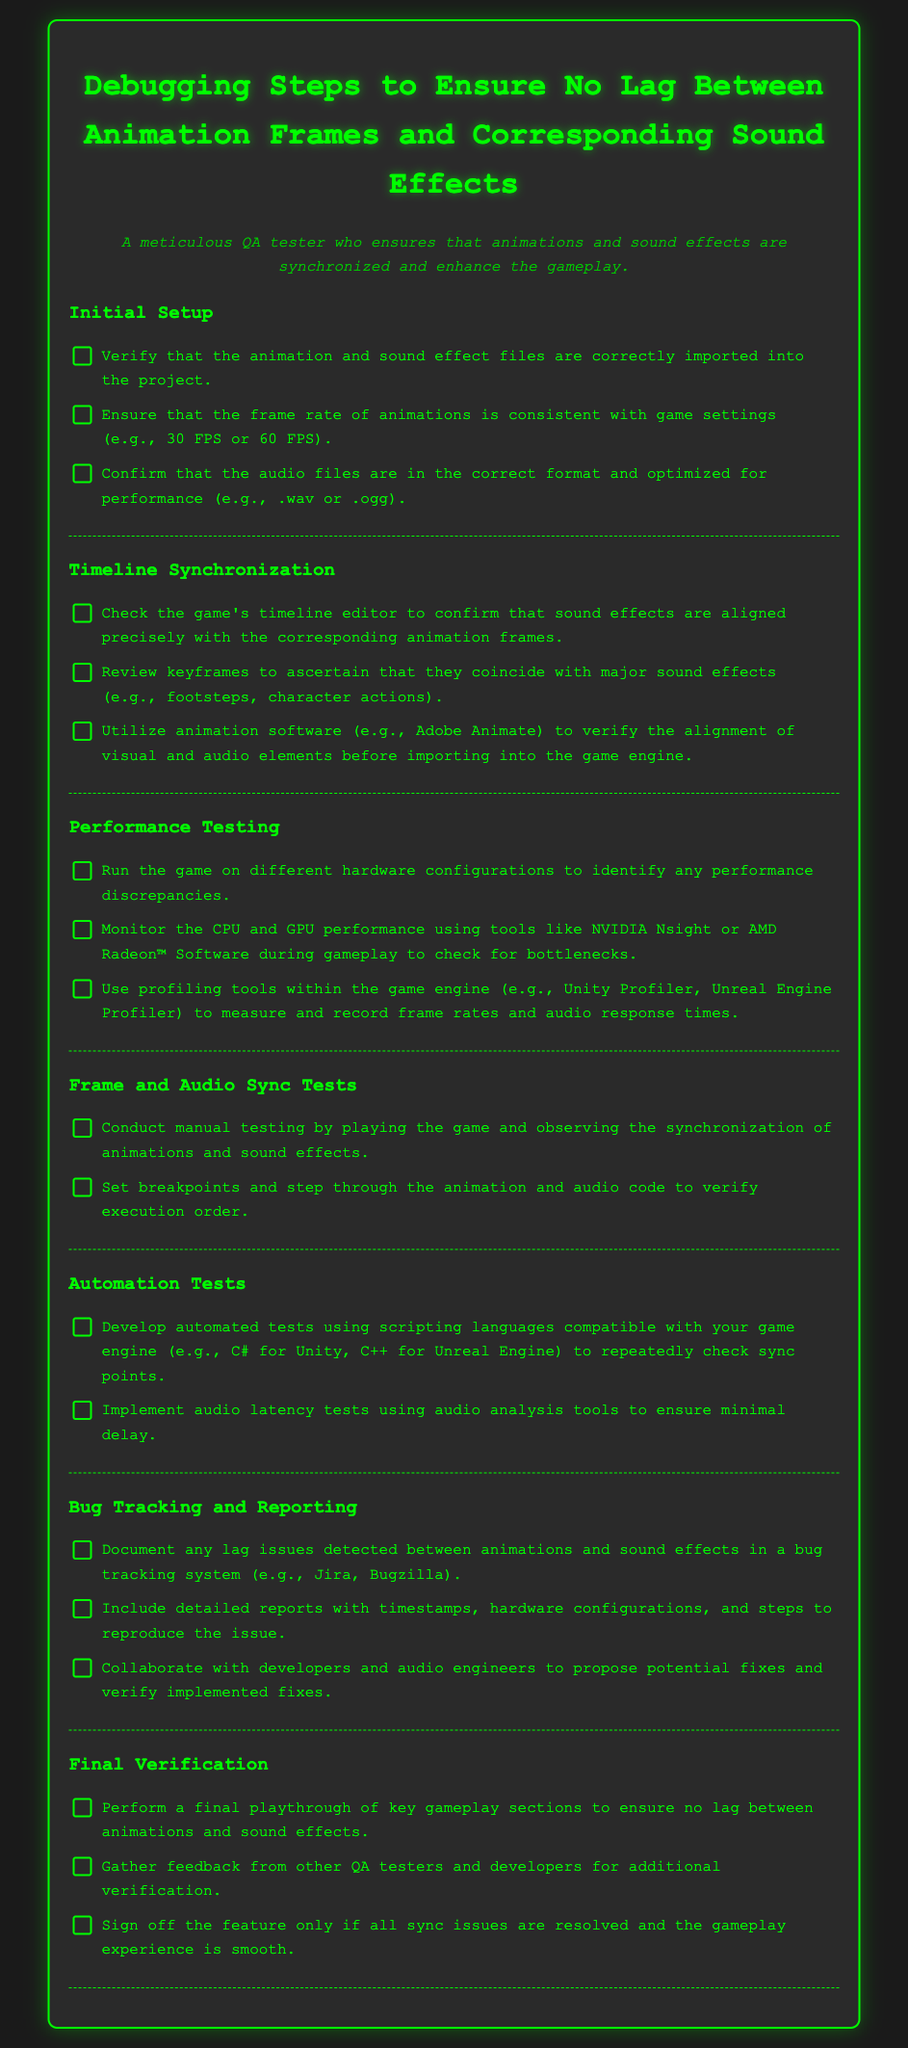what is the title of the document? The title is specified at the top of the document, indicating the focus on debugging animation and sound effects synchronization.
Answer: Debugging Steps to Ensure No Lag Between Animation Frames and Corresponding Sound Effects how many sections are there in the checklist? The document is divided into multiple sections, each addressing a different aspect of debugging.
Answer: 6 what is one of the audio formats mentioned that should be optimized for performance? The document specifies audio formats that are recommended for performance optimization within the game.
Answer: .wav which section includes steps for manual testing? The section details the methods for conducting manual tests focusing on synchronization of animations and sound effects.
Answer: Frame and Audio Sync Tests name a tool mentioned for monitoring performance during gameplay. The checklist lists specific tools for monitoring hardware performance during gameplay testing scenarios.
Answer: NVIDIA Nsight what is advised before signing off the feature? The checklist includes steps to verify and conclude the debugging process before final approval of gameplay features.
Answer: Final playthrough of key gameplay sections 